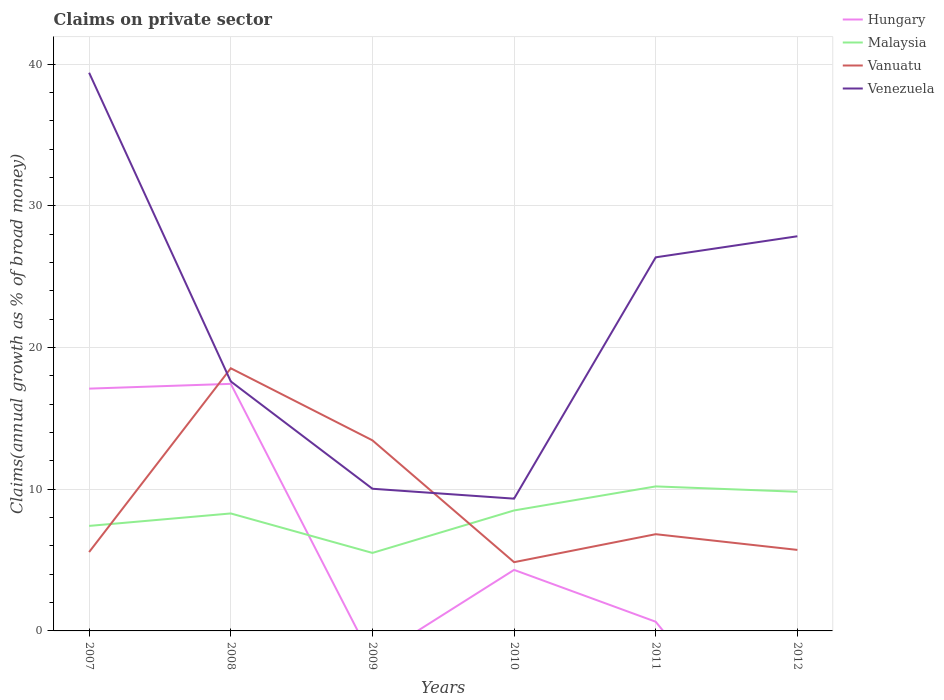How many different coloured lines are there?
Provide a succinct answer. 4. Does the line corresponding to Malaysia intersect with the line corresponding to Hungary?
Your answer should be compact. Yes. Is the number of lines equal to the number of legend labels?
Ensure brevity in your answer.  No. Across all years, what is the maximum percentage of broad money claimed on private sector in Malaysia?
Offer a terse response. 5.5. What is the total percentage of broad money claimed on private sector in Vanuatu in the graph?
Give a very brief answer. -12.97. What is the difference between the highest and the second highest percentage of broad money claimed on private sector in Hungary?
Your response must be concise. 17.44. What is the difference between the highest and the lowest percentage of broad money claimed on private sector in Venezuela?
Make the answer very short. 3. How many years are there in the graph?
Offer a very short reply. 6. Are the values on the major ticks of Y-axis written in scientific E-notation?
Provide a short and direct response. No. How are the legend labels stacked?
Provide a short and direct response. Vertical. What is the title of the graph?
Provide a succinct answer. Claims on private sector. Does "Northern Mariana Islands" appear as one of the legend labels in the graph?
Ensure brevity in your answer.  No. What is the label or title of the Y-axis?
Provide a succinct answer. Claims(annual growth as % of broad money). What is the Claims(annual growth as % of broad money) in Hungary in 2007?
Ensure brevity in your answer.  17.1. What is the Claims(annual growth as % of broad money) in Malaysia in 2007?
Provide a short and direct response. 7.41. What is the Claims(annual growth as % of broad money) in Vanuatu in 2007?
Provide a succinct answer. 5.57. What is the Claims(annual growth as % of broad money) of Venezuela in 2007?
Keep it short and to the point. 39.39. What is the Claims(annual growth as % of broad money) of Hungary in 2008?
Provide a succinct answer. 17.44. What is the Claims(annual growth as % of broad money) in Malaysia in 2008?
Provide a succinct answer. 8.29. What is the Claims(annual growth as % of broad money) of Vanuatu in 2008?
Provide a short and direct response. 18.54. What is the Claims(annual growth as % of broad money) of Venezuela in 2008?
Offer a very short reply. 17.61. What is the Claims(annual growth as % of broad money) of Malaysia in 2009?
Ensure brevity in your answer.  5.5. What is the Claims(annual growth as % of broad money) in Vanuatu in 2009?
Your response must be concise. 13.45. What is the Claims(annual growth as % of broad money) of Venezuela in 2009?
Your response must be concise. 10.03. What is the Claims(annual growth as % of broad money) in Hungary in 2010?
Offer a terse response. 4.31. What is the Claims(annual growth as % of broad money) of Malaysia in 2010?
Your answer should be very brief. 8.5. What is the Claims(annual growth as % of broad money) in Vanuatu in 2010?
Provide a short and direct response. 4.85. What is the Claims(annual growth as % of broad money) in Venezuela in 2010?
Give a very brief answer. 9.33. What is the Claims(annual growth as % of broad money) of Hungary in 2011?
Provide a short and direct response. 0.65. What is the Claims(annual growth as % of broad money) in Malaysia in 2011?
Your answer should be very brief. 10.2. What is the Claims(annual growth as % of broad money) in Vanuatu in 2011?
Offer a very short reply. 6.83. What is the Claims(annual growth as % of broad money) in Venezuela in 2011?
Your answer should be compact. 26.37. What is the Claims(annual growth as % of broad money) of Hungary in 2012?
Your answer should be very brief. 0. What is the Claims(annual growth as % of broad money) in Malaysia in 2012?
Keep it short and to the point. 9.82. What is the Claims(annual growth as % of broad money) in Vanuatu in 2012?
Provide a short and direct response. 5.72. What is the Claims(annual growth as % of broad money) in Venezuela in 2012?
Ensure brevity in your answer.  27.85. Across all years, what is the maximum Claims(annual growth as % of broad money) of Hungary?
Your answer should be compact. 17.44. Across all years, what is the maximum Claims(annual growth as % of broad money) of Malaysia?
Keep it short and to the point. 10.2. Across all years, what is the maximum Claims(annual growth as % of broad money) of Vanuatu?
Your answer should be compact. 18.54. Across all years, what is the maximum Claims(annual growth as % of broad money) in Venezuela?
Your response must be concise. 39.39. Across all years, what is the minimum Claims(annual growth as % of broad money) in Malaysia?
Make the answer very short. 5.5. Across all years, what is the minimum Claims(annual growth as % of broad money) in Vanuatu?
Your response must be concise. 4.85. Across all years, what is the minimum Claims(annual growth as % of broad money) of Venezuela?
Your answer should be compact. 9.33. What is the total Claims(annual growth as % of broad money) of Hungary in the graph?
Make the answer very short. 39.49. What is the total Claims(annual growth as % of broad money) in Malaysia in the graph?
Your answer should be very brief. 49.73. What is the total Claims(annual growth as % of broad money) in Vanuatu in the graph?
Give a very brief answer. 54.95. What is the total Claims(annual growth as % of broad money) of Venezuela in the graph?
Provide a succinct answer. 130.59. What is the difference between the Claims(annual growth as % of broad money) in Hungary in 2007 and that in 2008?
Give a very brief answer. -0.34. What is the difference between the Claims(annual growth as % of broad money) in Malaysia in 2007 and that in 2008?
Provide a short and direct response. -0.88. What is the difference between the Claims(annual growth as % of broad money) in Vanuatu in 2007 and that in 2008?
Your answer should be very brief. -12.97. What is the difference between the Claims(annual growth as % of broad money) of Venezuela in 2007 and that in 2008?
Your response must be concise. 21.78. What is the difference between the Claims(annual growth as % of broad money) of Malaysia in 2007 and that in 2009?
Provide a succinct answer. 1.91. What is the difference between the Claims(annual growth as % of broad money) of Vanuatu in 2007 and that in 2009?
Offer a terse response. -7.88. What is the difference between the Claims(annual growth as % of broad money) in Venezuela in 2007 and that in 2009?
Your response must be concise. 29.36. What is the difference between the Claims(annual growth as % of broad money) in Hungary in 2007 and that in 2010?
Offer a very short reply. 12.79. What is the difference between the Claims(annual growth as % of broad money) in Malaysia in 2007 and that in 2010?
Your answer should be compact. -1.09. What is the difference between the Claims(annual growth as % of broad money) in Vanuatu in 2007 and that in 2010?
Your response must be concise. 0.71. What is the difference between the Claims(annual growth as % of broad money) in Venezuela in 2007 and that in 2010?
Your answer should be very brief. 30.06. What is the difference between the Claims(annual growth as % of broad money) of Hungary in 2007 and that in 2011?
Provide a short and direct response. 16.45. What is the difference between the Claims(annual growth as % of broad money) in Malaysia in 2007 and that in 2011?
Provide a short and direct response. -2.79. What is the difference between the Claims(annual growth as % of broad money) of Vanuatu in 2007 and that in 2011?
Your response must be concise. -1.26. What is the difference between the Claims(annual growth as % of broad money) of Venezuela in 2007 and that in 2011?
Provide a short and direct response. 13.03. What is the difference between the Claims(annual growth as % of broad money) in Malaysia in 2007 and that in 2012?
Your answer should be compact. -2.41. What is the difference between the Claims(annual growth as % of broad money) of Vanuatu in 2007 and that in 2012?
Make the answer very short. -0.15. What is the difference between the Claims(annual growth as % of broad money) of Venezuela in 2007 and that in 2012?
Keep it short and to the point. 11.54. What is the difference between the Claims(annual growth as % of broad money) in Malaysia in 2008 and that in 2009?
Your answer should be compact. 2.79. What is the difference between the Claims(annual growth as % of broad money) of Vanuatu in 2008 and that in 2009?
Offer a very short reply. 5.09. What is the difference between the Claims(annual growth as % of broad money) of Venezuela in 2008 and that in 2009?
Ensure brevity in your answer.  7.58. What is the difference between the Claims(annual growth as % of broad money) in Hungary in 2008 and that in 2010?
Provide a short and direct response. 13.13. What is the difference between the Claims(annual growth as % of broad money) in Malaysia in 2008 and that in 2010?
Ensure brevity in your answer.  -0.21. What is the difference between the Claims(annual growth as % of broad money) in Vanuatu in 2008 and that in 2010?
Provide a succinct answer. 13.68. What is the difference between the Claims(annual growth as % of broad money) in Venezuela in 2008 and that in 2010?
Ensure brevity in your answer.  8.27. What is the difference between the Claims(annual growth as % of broad money) in Hungary in 2008 and that in 2011?
Keep it short and to the point. 16.79. What is the difference between the Claims(annual growth as % of broad money) of Malaysia in 2008 and that in 2011?
Ensure brevity in your answer.  -1.91. What is the difference between the Claims(annual growth as % of broad money) in Vanuatu in 2008 and that in 2011?
Offer a terse response. 11.71. What is the difference between the Claims(annual growth as % of broad money) in Venezuela in 2008 and that in 2011?
Provide a short and direct response. -8.76. What is the difference between the Claims(annual growth as % of broad money) of Malaysia in 2008 and that in 2012?
Give a very brief answer. -1.53. What is the difference between the Claims(annual growth as % of broad money) of Vanuatu in 2008 and that in 2012?
Ensure brevity in your answer.  12.82. What is the difference between the Claims(annual growth as % of broad money) of Venezuela in 2008 and that in 2012?
Your response must be concise. -10.24. What is the difference between the Claims(annual growth as % of broad money) of Malaysia in 2009 and that in 2010?
Offer a very short reply. -3. What is the difference between the Claims(annual growth as % of broad money) of Vanuatu in 2009 and that in 2010?
Provide a succinct answer. 8.6. What is the difference between the Claims(annual growth as % of broad money) of Venezuela in 2009 and that in 2010?
Provide a succinct answer. 0.7. What is the difference between the Claims(annual growth as % of broad money) of Malaysia in 2009 and that in 2011?
Offer a very short reply. -4.69. What is the difference between the Claims(annual growth as % of broad money) of Vanuatu in 2009 and that in 2011?
Offer a terse response. 6.62. What is the difference between the Claims(annual growth as % of broad money) in Venezuela in 2009 and that in 2011?
Give a very brief answer. -16.33. What is the difference between the Claims(annual growth as % of broad money) in Malaysia in 2009 and that in 2012?
Offer a very short reply. -4.32. What is the difference between the Claims(annual growth as % of broad money) in Vanuatu in 2009 and that in 2012?
Provide a short and direct response. 7.73. What is the difference between the Claims(annual growth as % of broad money) of Venezuela in 2009 and that in 2012?
Your response must be concise. -17.82. What is the difference between the Claims(annual growth as % of broad money) in Hungary in 2010 and that in 2011?
Offer a terse response. 3.66. What is the difference between the Claims(annual growth as % of broad money) in Malaysia in 2010 and that in 2011?
Your response must be concise. -1.7. What is the difference between the Claims(annual growth as % of broad money) of Vanuatu in 2010 and that in 2011?
Your response must be concise. -1.97. What is the difference between the Claims(annual growth as % of broad money) in Venezuela in 2010 and that in 2011?
Make the answer very short. -17.03. What is the difference between the Claims(annual growth as % of broad money) in Malaysia in 2010 and that in 2012?
Provide a short and direct response. -1.32. What is the difference between the Claims(annual growth as % of broad money) in Vanuatu in 2010 and that in 2012?
Your response must be concise. -0.87. What is the difference between the Claims(annual growth as % of broad money) in Venezuela in 2010 and that in 2012?
Offer a very short reply. -18.52. What is the difference between the Claims(annual growth as % of broad money) of Malaysia in 2011 and that in 2012?
Your answer should be very brief. 0.38. What is the difference between the Claims(annual growth as % of broad money) of Vanuatu in 2011 and that in 2012?
Give a very brief answer. 1.11. What is the difference between the Claims(annual growth as % of broad money) of Venezuela in 2011 and that in 2012?
Your answer should be compact. -1.49. What is the difference between the Claims(annual growth as % of broad money) in Hungary in 2007 and the Claims(annual growth as % of broad money) in Malaysia in 2008?
Provide a short and direct response. 8.81. What is the difference between the Claims(annual growth as % of broad money) of Hungary in 2007 and the Claims(annual growth as % of broad money) of Vanuatu in 2008?
Give a very brief answer. -1.44. What is the difference between the Claims(annual growth as % of broad money) in Hungary in 2007 and the Claims(annual growth as % of broad money) in Venezuela in 2008?
Provide a succinct answer. -0.51. What is the difference between the Claims(annual growth as % of broad money) of Malaysia in 2007 and the Claims(annual growth as % of broad money) of Vanuatu in 2008?
Offer a terse response. -11.13. What is the difference between the Claims(annual growth as % of broad money) of Malaysia in 2007 and the Claims(annual growth as % of broad money) of Venezuela in 2008?
Your response must be concise. -10.2. What is the difference between the Claims(annual growth as % of broad money) of Vanuatu in 2007 and the Claims(annual growth as % of broad money) of Venezuela in 2008?
Provide a succinct answer. -12.04. What is the difference between the Claims(annual growth as % of broad money) in Hungary in 2007 and the Claims(annual growth as % of broad money) in Malaysia in 2009?
Offer a very short reply. 11.6. What is the difference between the Claims(annual growth as % of broad money) of Hungary in 2007 and the Claims(annual growth as % of broad money) of Vanuatu in 2009?
Ensure brevity in your answer.  3.65. What is the difference between the Claims(annual growth as % of broad money) in Hungary in 2007 and the Claims(annual growth as % of broad money) in Venezuela in 2009?
Keep it short and to the point. 7.07. What is the difference between the Claims(annual growth as % of broad money) in Malaysia in 2007 and the Claims(annual growth as % of broad money) in Vanuatu in 2009?
Make the answer very short. -6.04. What is the difference between the Claims(annual growth as % of broad money) in Malaysia in 2007 and the Claims(annual growth as % of broad money) in Venezuela in 2009?
Ensure brevity in your answer.  -2.62. What is the difference between the Claims(annual growth as % of broad money) of Vanuatu in 2007 and the Claims(annual growth as % of broad money) of Venezuela in 2009?
Offer a terse response. -4.47. What is the difference between the Claims(annual growth as % of broad money) in Hungary in 2007 and the Claims(annual growth as % of broad money) in Malaysia in 2010?
Ensure brevity in your answer.  8.6. What is the difference between the Claims(annual growth as % of broad money) in Hungary in 2007 and the Claims(annual growth as % of broad money) in Vanuatu in 2010?
Your answer should be very brief. 12.25. What is the difference between the Claims(annual growth as % of broad money) of Hungary in 2007 and the Claims(annual growth as % of broad money) of Venezuela in 2010?
Provide a succinct answer. 7.76. What is the difference between the Claims(annual growth as % of broad money) of Malaysia in 2007 and the Claims(annual growth as % of broad money) of Vanuatu in 2010?
Ensure brevity in your answer.  2.56. What is the difference between the Claims(annual growth as % of broad money) of Malaysia in 2007 and the Claims(annual growth as % of broad money) of Venezuela in 2010?
Offer a terse response. -1.92. What is the difference between the Claims(annual growth as % of broad money) of Vanuatu in 2007 and the Claims(annual growth as % of broad money) of Venezuela in 2010?
Offer a very short reply. -3.77. What is the difference between the Claims(annual growth as % of broad money) of Hungary in 2007 and the Claims(annual growth as % of broad money) of Malaysia in 2011?
Keep it short and to the point. 6.9. What is the difference between the Claims(annual growth as % of broad money) of Hungary in 2007 and the Claims(annual growth as % of broad money) of Vanuatu in 2011?
Provide a short and direct response. 10.27. What is the difference between the Claims(annual growth as % of broad money) of Hungary in 2007 and the Claims(annual growth as % of broad money) of Venezuela in 2011?
Give a very brief answer. -9.27. What is the difference between the Claims(annual growth as % of broad money) in Malaysia in 2007 and the Claims(annual growth as % of broad money) in Vanuatu in 2011?
Make the answer very short. 0.58. What is the difference between the Claims(annual growth as % of broad money) of Malaysia in 2007 and the Claims(annual growth as % of broad money) of Venezuela in 2011?
Provide a short and direct response. -18.95. What is the difference between the Claims(annual growth as % of broad money) of Vanuatu in 2007 and the Claims(annual growth as % of broad money) of Venezuela in 2011?
Keep it short and to the point. -20.8. What is the difference between the Claims(annual growth as % of broad money) in Hungary in 2007 and the Claims(annual growth as % of broad money) in Malaysia in 2012?
Give a very brief answer. 7.28. What is the difference between the Claims(annual growth as % of broad money) in Hungary in 2007 and the Claims(annual growth as % of broad money) in Vanuatu in 2012?
Make the answer very short. 11.38. What is the difference between the Claims(annual growth as % of broad money) of Hungary in 2007 and the Claims(annual growth as % of broad money) of Venezuela in 2012?
Make the answer very short. -10.75. What is the difference between the Claims(annual growth as % of broad money) in Malaysia in 2007 and the Claims(annual growth as % of broad money) in Vanuatu in 2012?
Give a very brief answer. 1.69. What is the difference between the Claims(annual growth as % of broad money) of Malaysia in 2007 and the Claims(annual growth as % of broad money) of Venezuela in 2012?
Your answer should be very brief. -20.44. What is the difference between the Claims(annual growth as % of broad money) in Vanuatu in 2007 and the Claims(annual growth as % of broad money) in Venezuela in 2012?
Provide a succinct answer. -22.29. What is the difference between the Claims(annual growth as % of broad money) of Hungary in 2008 and the Claims(annual growth as % of broad money) of Malaysia in 2009?
Keep it short and to the point. 11.93. What is the difference between the Claims(annual growth as % of broad money) in Hungary in 2008 and the Claims(annual growth as % of broad money) in Vanuatu in 2009?
Your answer should be very brief. 3.99. What is the difference between the Claims(annual growth as % of broad money) of Hungary in 2008 and the Claims(annual growth as % of broad money) of Venezuela in 2009?
Give a very brief answer. 7.4. What is the difference between the Claims(annual growth as % of broad money) in Malaysia in 2008 and the Claims(annual growth as % of broad money) in Vanuatu in 2009?
Provide a short and direct response. -5.16. What is the difference between the Claims(annual growth as % of broad money) in Malaysia in 2008 and the Claims(annual growth as % of broad money) in Venezuela in 2009?
Provide a short and direct response. -1.74. What is the difference between the Claims(annual growth as % of broad money) in Vanuatu in 2008 and the Claims(annual growth as % of broad money) in Venezuela in 2009?
Offer a very short reply. 8.5. What is the difference between the Claims(annual growth as % of broad money) of Hungary in 2008 and the Claims(annual growth as % of broad money) of Malaysia in 2010?
Offer a terse response. 8.93. What is the difference between the Claims(annual growth as % of broad money) in Hungary in 2008 and the Claims(annual growth as % of broad money) in Vanuatu in 2010?
Offer a very short reply. 12.58. What is the difference between the Claims(annual growth as % of broad money) in Hungary in 2008 and the Claims(annual growth as % of broad money) in Venezuela in 2010?
Give a very brief answer. 8.1. What is the difference between the Claims(annual growth as % of broad money) in Malaysia in 2008 and the Claims(annual growth as % of broad money) in Vanuatu in 2010?
Ensure brevity in your answer.  3.44. What is the difference between the Claims(annual growth as % of broad money) of Malaysia in 2008 and the Claims(annual growth as % of broad money) of Venezuela in 2010?
Your response must be concise. -1.04. What is the difference between the Claims(annual growth as % of broad money) of Vanuatu in 2008 and the Claims(annual growth as % of broad money) of Venezuela in 2010?
Your answer should be very brief. 9.2. What is the difference between the Claims(annual growth as % of broad money) in Hungary in 2008 and the Claims(annual growth as % of broad money) in Malaysia in 2011?
Keep it short and to the point. 7.24. What is the difference between the Claims(annual growth as % of broad money) of Hungary in 2008 and the Claims(annual growth as % of broad money) of Vanuatu in 2011?
Your answer should be compact. 10.61. What is the difference between the Claims(annual growth as % of broad money) in Hungary in 2008 and the Claims(annual growth as % of broad money) in Venezuela in 2011?
Offer a very short reply. -8.93. What is the difference between the Claims(annual growth as % of broad money) in Malaysia in 2008 and the Claims(annual growth as % of broad money) in Vanuatu in 2011?
Your answer should be compact. 1.46. What is the difference between the Claims(annual growth as % of broad money) of Malaysia in 2008 and the Claims(annual growth as % of broad money) of Venezuela in 2011?
Ensure brevity in your answer.  -18.08. What is the difference between the Claims(annual growth as % of broad money) in Vanuatu in 2008 and the Claims(annual growth as % of broad money) in Venezuela in 2011?
Provide a succinct answer. -7.83. What is the difference between the Claims(annual growth as % of broad money) in Hungary in 2008 and the Claims(annual growth as % of broad money) in Malaysia in 2012?
Provide a succinct answer. 7.62. What is the difference between the Claims(annual growth as % of broad money) in Hungary in 2008 and the Claims(annual growth as % of broad money) in Vanuatu in 2012?
Provide a succinct answer. 11.72. What is the difference between the Claims(annual growth as % of broad money) of Hungary in 2008 and the Claims(annual growth as % of broad money) of Venezuela in 2012?
Your answer should be very brief. -10.42. What is the difference between the Claims(annual growth as % of broad money) in Malaysia in 2008 and the Claims(annual growth as % of broad money) in Vanuatu in 2012?
Your answer should be very brief. 2.57. What is the difference between the Claims(annual growth as % of broad money) of Malaysia in 2008 and the Claims(annual growth as % of broad money) of Venezuela in 2012?
Your response must be concise. -19.56. What is the difference between the Claims(annual growth as % of broad money) in Vanuatu in 2008 and the Claims(annual growth as % of broad money) in Venezuela in 2012?
Keep it short and to the point. -9.32. What is the difference between the Claims(annual growth as % of broad money) of Malaysia in 2009 and the Claims(annual growth as % of broad money) of Vanuatu in 2010?
Provide a succinct answer. 0.65. What is the difference between the Claims(annual growth as % of broad money) in Malaysia in 2009 and the Claims(annual growth as % of broad money) in Venezuela in 2010?
Offer a terse response. -3.83. What is the difference between the Claims(annual growth as % of broad money) of Vanuatu in 2009 and the Claims(annual growth as % of broad money) of Venezuela in 2010?
Provide a succinct answer. 4.12. What is the difference between the Claims(annual growth as % of broad money) in Malaysia in 2009 and the Claims(annual growth as % of broad money) in Vanuatu in 2011?
Your response must be concise. -1.32. What is the difference between the Claims(annual growth as % of broad money) of Malaysia in 2009 and the Claims(annual growth as % of broad money) of Venezuela in 2011?
Provide a short and direct response. -20.86. What is the difference between the Claims(annual growth as % of broad money) of Vanuatu in 2009 and the Claims(annual growth as % of broad money) of Venezuela in 2011?
Your response must be concise. -12.92. What is the difference between the Claims(annual growth as % of broad money) of Malaysia in 2009 and the Claims(annual growth as % of broad money) of Vanuatu in 2012?
Keep it short and to the point. -0.21. What is the difference between the Claims(annual growth as % of broad money) in Malaysia in 2009 and the Claims(annual growth as % of broad money) in Venezuela in 2012?
Make the answer very short. -22.35. What is the difference between the Claims(annual growth as % of broad money) of Vanuatu in 2009 and the Claims(annual growth as % of broad money) of Venezuela in 2012?
Your response must be concise. -14.4. What is the difference between the Claims(annual growth as % of broad money) in Hungary in 2010 and the Claims(annual growth as % of broad money) in Malaysia in 2011?
Provide a succinct answer. -5.89. What is the difference between the Claims(annual growth as % of broad money) in Hungary in 2010 and the Claims(annual growth as % of broad money) in Vanuatu in 2011?
Offer a very short reply. -2.52. What is the difference between the Claims(annual growth as % of broad money) of Hungary in 2010 and the Claims(annual growth as % of broad money) of Venezuela in 2011?
Make the answer very short. -22.06. What is the difference between the Claims(annual growth as % of broad money) of Malaysia in 2010 and the Claims(annual growth as % of broad money) of Vanuatu in 2011?
Your answer should be very brief. 1.68. What is the difference between the Claims(annual growth as % of broad money) of Malaysia in 2010 and the Claims(annual growth as % of broad money) of Venezuela in 2011?
Ensure brevity in your answer.  -17.86. What is the difference between the Claims(annual growth as % of broad money) in Vanuatu in 2010 and the Claims(annual growth as % of broad money) in Venezuela in 2011?
Provide a short and direct response. -21.51. What is the difference between the Claims(annual growth as % of broad money) of Hungary in 2010 and the Claims(annual growth as % of broad money) of Malaysia in 2012?
Your answer should be very brief. -5.51. What is the difference between the Claims(annual growth as % of broad money) in Hungary in 2010 and the Claims(annual growth as % of broad money) in Vanuatu in 2012?
Offer a terse response. -1.41. What is the difference between the Claims(annual growth as % of broad money) of Hungary in 2010 and the Claims(annual growth as % of broad money) of Venezuela in 2012?
Provide a succinct answer. -23.55. What is the difference between the Claims(annual growth as % of broad money) of Malaysia in 2010 and the Claims(annual growth as % of broad money) of Vanuatu in 2012?
Your answer should be very brief. 2.78. What is the difference between the Claims(annual growth as % of broad money) in Malaysia in 2010 and the Claims(annual growth as % of broad money) in Venezuela in 2012?
Provide a succinct answer. -19.35. What is the difference between the Claims(annual growth as % of broad money) in Vanuatu in 2010 and the Claims(annual growth as % of broad money) in Venezuela in 2012?
Ensure brevity in your answer.  -23. What is the difference between the Claims(annual growth as % of broad money) of Hungary in 2011 and the Claims(annual growth as % of broad money) of Malaysia in 2012?
Your response must be concise. -9.17. What is the difference between the Claims(annual growth as % of broad money) in Hungary in 2011 and the Claims(annual growth as % of broad money) in Vanuatu in 2012?
Offer a terse response. -5.07. What is the difference between the Claims(annual growth as % of broad money) of Hungary in 2011 and the Claims(annual growth as % of broad money) of Venezuela in 2012?
Your response must be concise. -27.2. What is the difference between the Claims(annual growth as % of broad money) of Malaysia in 2011 and the Claims(annual growth as % of broad money) of Vanuatu in 2012?
Provide a succinct answer. 4.48. What is the difference between the Claims(annual growth as % of broad money) in Malaysia in 2011 and the Claims(annual growth as % of broad money) in Venezuela in 2012?
Make the answer very short. -17.65. What is the difference between the Claims(annual growth as % of broad money) in Vanuatu in 2011 and the Claims(annual growth as % of broad money) in Venezuela in 2012?
Provide a succinct answer. -21.03. What is the average Claims(annual growth as % of broad money) in Hungary per year?
Your answer should be compact. 6.58. What is the average Claims(annual growth as % of broad money) in Malaysia per year?
Offer a terse response. 8.29. What is the average Claims(annual growth as % of broad money) of Vanuatu per year?
Make the answer very short. 9.16. What is the average Claims(annual growth as % of broad money) in Venezuela per year?
Your answer should be compact. 21.77. In the year 2007, what is the difference between the Claims(annual growth as % of broad money) in Hungary and Claims(annual growth as % of broad money) in Malaysia?
Provide a succinct answer. 9.69. In the year 2007, what is the difference between the Claims(annual growth as % of broad money) in Hungary and Claims(annual growth as % of broad money) in Vanuatu?
Offer a very short reply. 11.53. In the year 2007, what is the difference between the Claims(annual growth as % of broad money) in Hungary and Claims(annual growth as % of broad money) in Venezuela?
Provide a succinct answer. -22.29. In the year 2007, what is the difference between the Claims(annual growth as % of broad money) of Malaysia and Claims(annual growth as % of broad money) of Vanuatu?
Provide a succinct answer. 1.84. In the year 2007, what is the difference between the Claims(annual growth as % of broad money) in Malaysia and Claims(annual growth as % of broad money) in Venezuela?
Keep it short and to the point. -31.98. In the year 2007, what is the difference between the Claims(annual growth as % of broad money) in Vanuatu and Claims(annual growth as % of broad money) in Venezuela?
Ensure brevity in your answer.  -33.83. In the year 2008, what is the difference between the Claims(annual growth as % of broad money) in Hungary and Claims(annual growth as % of broad money) in Malaysia?
Give a very brief answer. 9.15. In the year 2008, what is the difference between the Claims(annual growth as % of broad money) of Hungary and Claims(annual growth as % of broad money) of Vanuatu?
Your response must be concise. -1.1. In the year 2008, what is the difference between the Claims(annual growth as % of broad money) in Hungary and Claims(annual growth as % of broad money) in Venezuela?
Provide a short and direct response. -0.17. In the year 2008, what is the difference between the Claims(annual growth as % of broad money) in Malaysia and Claims(annual growth as % of broad money) in Vanuatu?
Ensure brevity in your answer.  -10.25. In the year 2008, what is the difference between the Claims(annual growth as % of broad money) of Malaysia and Claims(annual growth as % of broad money) of Venezuela?
Your response must be concise. -9.32. In the year 2008, what is the difference between the Claims(annual growth as % of broad money) in Vanuatu and Claims(annual growth as % of broad money) in Venezuela?
Provide a short and direct response. 0.93. In the year 2009, what is the difference between the Claims(annual growth as % of broad money) in Malaysia and Claims(annual growth as % of broad money) in Vanuatu?
Offer a very short reply. -7.95. In the year 2009, what is the difference between the Claims(annual growth as % of broad money) of Malaysia and Claims(annual growth as % of broad money) of Venezuela?
Your answer should be very brief. -4.53. In the year 2009, what is the difference between the Claims(annual growth as % of broad money) in Vanuatu and Claims(annual growth as % of broad money) in Venezuela?
Provide a short and direct response. 3.42. In the year 2010, what is the difference between the Claims(annual growth as % of broad money) in Hungary and Claims(annual growth as % of broad money) in Malaysia?
Your answer should be compact. -4.2. In the year 2010, what is the difference between the Claims(annual growth as % of broad money) in Hungary and Claims(annual growth as % of broad money) in Vanuatu?
Ensure brevity in your answer.  -0.54. In the year 2010, what is the difference between the Claims(annual growth as % of broad money) in Hungary and Claims(annual growth as % of broad money) in Venezuela?
Keep it short and to the point. -5.03. In the year 2010, what is the difference between the Claims(annual growth as % of broad money) of Malaysia and Claims(annual growth as % of broad money) of Vanuatu?
Give a very brief answer. 3.65. In the year 2010, what is the difference between the Claims(annual growth as % of broad money) in Malaysia and Claims(annual growth as % of broad money) in Venezuela?
Offer a terse response. -0.83. In the year 2010, what is the difference between the Claims(annual growth as % of broad money) in Vanuatu and Claims(annual growth as % of broad money) in Venezuela?
Offer a very short reply. -4.48. In the year 2011, what is the difference between the Claims(annual growth as % of broad money) in Hungary and Claims(annual growth as % of broad money) in Malaysia?
Provide a succinct answer. -9.55. In the year 2011, what is the difference between the Claims(annual growth as % of broad money) in Hungary and Claims(annual growth as % of broad money) in Vanuatu?
Offer a very short reply. -6.18. In the year 2011, what is the difference between the Claims(annual growth as % of broad money) of Hungary and Claims(annual growth as % of broad money) of Venezuela?
Provide a short and direct response. -25.72. In the year 2011, what is the difference between the Claims(annual growth as % of broad money) in Malaysia and Claims(annual growth as % of broad money) in Vanuatu?
Keep it short and to the point. 3.37. In the year 2011, what is the difference between the Claims(annual growth as % of broad money) in Malaysia and Claims(annual growth as % of broad money) in Venezuela?
Your response must be concise. -16.17. In the year 2011, what is the difference between the Claims(annual growth as % of broad money) of Vanuatu and Claims(annual growth as % of broad money) of Venezuela?
Keep it short and to the point. -19.54. In the year 2012, what is the difference between the Claims(annual growth as % of broad money) of Malaysia and Claims(annual growth as % of broad money) of Vanuatu?
Provide a short and direct response. 4.1. In the year 2012, what is the difference between the Claims(annual growth as % of broad money) of Malaysia and Claims(annual growth as % of broad money) of Venezuela?
Your response must be concise. -18.03. In the year 2012, what is the difference between the Claims(annual growth as % of broad money) in Vanuatu and Claims(annual growth as % of broad money) in Venezuela?
Give a very brief answer. -22.14. What is the ratio of the Claims(annual growth as % of broad money) in Hungary in 2007 to that in 2008?
Provide a succinct answer. 0.98. What is the ratio of the Claims(annual growth as % of broad money) of Malaysia in 2007 to that in 2008?
Offer a very short reply. 0.89. What is the ratio of the Claims(annual growth as % of broad money) of Vanuatu in 2007 to that in 2008?
Offer a terse response. 0.3. What is the ratio of the Claims(annual growth as % of broad money) of Venezuela in 2007 to that in 2008?
Your answer should be compact. 2.24. What is the ratio of the Claims(annual growth as % of broad money) of Malaysia in 2007 to that in 2009?
Keep it short and to the point. 1.35. What is the ratio of the Claims(annual growth as % of broad money) in Vanuatu in 2007 to that in 2009?
Your answer should be very brief. 0.41. What is the ratio of the Claims(annual growth as % of broad money) in Venezuela in 2007 to that in 2009?
Provide a short and direct response. 3.93. What is the ratio of the Claims(annual growth as % of broad money) in Hungary in 2007 to that in 2010?
Give a very brief answer. 3.97. What is the ratio of the Claims(annual growth as % of broad money) of Malaysia in 2007 to that in 2010?
Give a very brief answer. 0.87. What is the ratio of the Claims(annual growth as % of broad money) of Vanuatu in 2007 to that in 2010?
Your response must be concise. 1.15. What is the ratio of the Claims(annual growth as % of broad money) of Venezuela in 2007 to that in 2010?
Offer a terse response. 4.22. What is the ratio of the Claims(annual growth as % of broad money) of Hungary in 2007 to that in 2011?
Make the answer very short. 26.38. What is the ratio of the Claims(annual growth as % of broad money) in Malaysia in 2007 to that in 2011?
Provide a succinct answer. 0.73. What is the ratio of the Claims(annual growth as % of broad money) in Vanuatu in 2007 to that in 2011?
Keep it short and to the point. 0.82. What is the ratio of the Claims(annual growth as % of broad money) in Venezuela in 2007 to that in 2011?
Offer a very short reply. 1.49. What is the ratio of the Claims(annual growth as % of broad money) in Malaysia in 2007 to that in 2012?
Provide a short and direct response. 0.75. What is the ratio of the Claims(annual growth as % of broad money) of Vanuatu in 2007 to that in 2012?
Offer a terse response. 0.97. What is the ratio of the Claims(annual growth as % of broad money) in Venezuela in 2007 to that in 2012?
Give a very brief answer. 1.41. What is the ratio of the Claims(annual growth as % of broad money) of Malaysia in 2008 to that in 2009?
Provide a succinct answer. 1.51. What is the ratio of the Claims(annual growth as % of broad money) in Vanuatu in 2008 to that in 2009?
Provide a succinct answer. 1.38. What is the ratio of the Claims(annual growth as % of broad money) in Venezuela in 2008 to that in 2009?
Your response must be concise. 1.75. What is the ratio of the Claims(annual growth as % of broad money) of Hungary in 2008 to that in 2010?
Provide a succinct answer. 4.05. What is the ratio of the Claims(annual growth as % of broad money) in Malaysia in 2008 to that in 2010?
Make the answer very short. 0.98. What is the ratio of the Claims(annual growth as % of broad money) in Vanuatu in 2008 to that in 2010?
Your answer should be compact. 3.82. What is the ratio of the Claims(annual growth as % of broad money) of Venezuela in 2008 to that in 2010?
Provide a succinct answer. 1.89. What is the ratio of the Claims(annual growth as % of broad money) in Hungary in 2008 to that in 2011?
Provide a short and direct response. 26.9. What is the ratio of the Claims(annual growth as % of broad money) in Malaysia in 2008 to that in 2011?
Provide a succinct answer. 0.81. What is the ratio of the Claims(annual growth as % of broad money) in Vanuatu in 2008 to that in 2011?
Your answer should be very brief. 2.72. What is the ratio of the Claims(annual growth as % of broad money) in Venezuela in 2008 to that in 2011?
Ensure brevity in your answer.  0.67. What is the ratio of the Claims(annual growth as % of broad money) of Malaysia in 2008 to that in 2012?
Ensure brevity in your answer.  0.84. What is the ratio of the Claims(annual growth as % of broad money) of Vanuatu in 2008 to that in 2012?
Your answer should be very brief. 3.24. What is the ratio of the Claims(annual growth as % of broad money) of Venezuela in 2008 to that in 2012?
Provide a short and direct response. 0.63. What is the ratio of the Claims(annual growth as % of broad money) in Malaysia in 2009 to that in 2010?
Ensure brevity in your answer.  0.65. What is the ratio of the Claims(annual growth as % of broad money) of Vanuatu in 2009 to that in 2010?
Offer a very short reply. 2.77. What is the ratio of the Claims(annual growth as % of broad money) in Venezuela in 2009 to that in 2010?
Your answer should be very brief. 1.07. What is the ratio of the Claims(annual growth as % of broad money) of Malaysia in 2009 to that in 2011?
Your answer should be compact. 0.54. What is the ratio of the Claims(annual growth as % of broad money) of Vanuatu in 2009 to that in 2011?
Your answer should be very brief. 1.97. What is the ratio of the Claims(annual growth as % of broad money) of Venezuela in 2009 to that in 2011?
Your response must be concise. 0.38. What is the ratio of the Claims(annual growth as % of broad money) of Malaysia in 2009 to that in 2012?
Give a very brief answer. 0.56. What is the ratio of the Claims(annual growth as % of broad money) in Vanuatu in 2009 to that in 2012?
Give a very brief answer. 2.35. What is the ratio of the Claims(annual growth as % of broad money) of Venezuela in 2009 to that in 2012?
Offer a terse response. 0.36. What is the ratio of the Claims(annual growth as % of broad money) in Hungary in 2010 to that in 2011?
Your response must be concise. 6.65. What is the ratio of the Claims(annual growth as % of broad money) in Malaysia in 2010 to that in 2011?
Your response must be concise. 0.83. What is the ratio of the Claims(annual growth as % of broad money) in Vanuatu in 2010 to that in 2011?
Keep it short and to the point. 0.71. What is the ratio of the Claims(annual growth as % of broad money) of Venezuela in 2010 to that in 2011?
Your response must be concise. 0.35. What is the ratio of the Claims(annual growth as % of broad money) in Malaysia in 2010 to that in 2012?
Offer a terse response. 0.87. What is the ratio of the Claims(annual growth as % of broad money) in Vanuatu in 2010 to that in 2012?
Make the answer very short. 0.85. What is the ratio of the Claims(annual growth as % of broad money) in Venezuela in 2010 to that in 2012?
Ensure brevity in your answer.  0.34. What is the ratio of the Claims(annual growth as % of broad money) in Malaysia in 2011 to that in 2012?
Your answer should be very brief. 1.04. What is the ratio of the Claims(annual growth as % of broad money) of Vanuatu in 2011 to that in 2012?
Offer a very short reply. 1.19. What is the ratio of the Claims(annual growth as % of broad money) of Venezuela in 2011 to that in 2012?
Your answer should be very brief. 0.95. What is the difference between the highest and the second highest Claims(annual growth as % of broad money) of Hungary?
Keep it short and to the point. 0.34. What is the difference between the highest and the second highest Claims(annual growth as % of broad money) of Malaysia?
Your answer should be compact. 0.38. What is the difference between the highest and the second highest Claims(annual growth as % of broad money) of Vanuatu?
Offer a terse response. 5.09. What is the difference between the highest and the second highest Claims(annual growth as % of broad money) in Venezuela?
Give a very brief answer. 11.54. What is the difference between the highest and the lowest Claims(annual growth as % of broad money) in Hungary?
Keep it short and to the point. 17.44. What is the difference between the highest and the lowest Claims(annual growth as % of broad money) in Malaysia?
Make the answer very short. 4.69. What is the difference between the highest and the lowest Claims(annual growth as % of broad money) of Vanuatu?
Provide a succinct answer. 13.68. What is the difference between the highest and the lowest Claims(annual growth as % of broad money) of Venezuela?
Your answer should be compact. 30.06. 